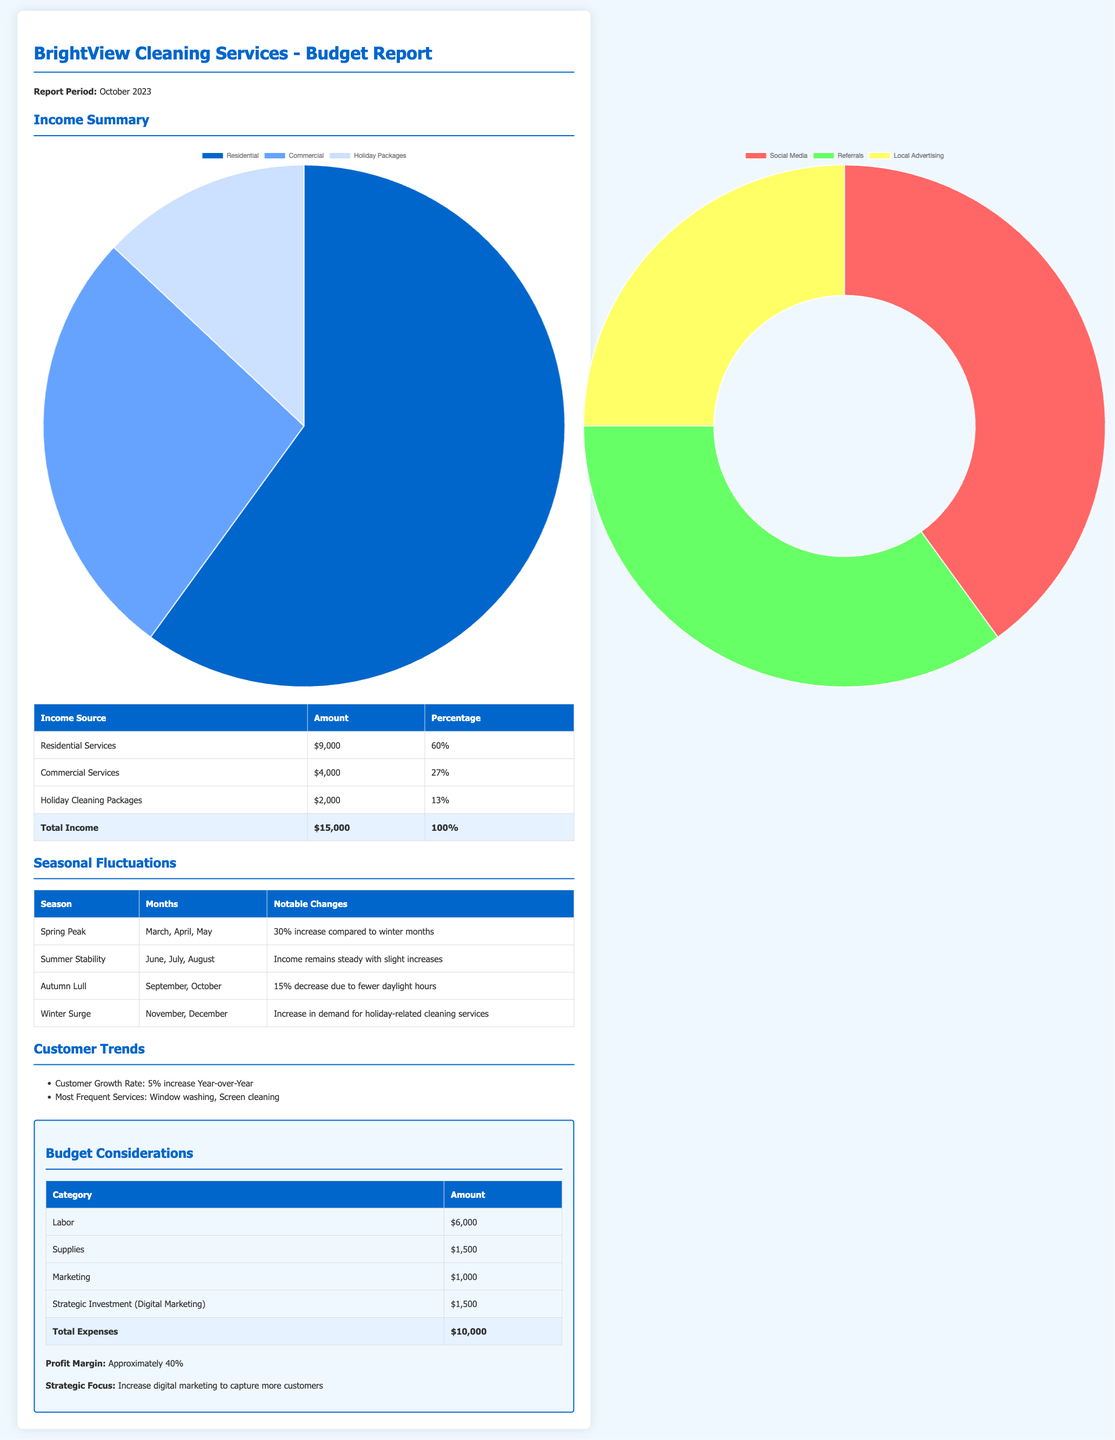What is the total income for October 2023? The total income is the sum of all the income sources listed, which is $9,000 + $4,000 + $2,000 = $15,000.
Answer: $15,000 What percentage of total income comes from residential services? Residential services account for 60% of the total income as stated in the income summary.
Answer: 60% What notable change occurs during the Autumn season? The document states that during Autumn, there is a 15% decrease in income due to fewer daylight hours.
Answer: 15% decrease What was the customer growth rate this year? The document mentions that the customer growth rate is a 5% increase year-over-year.
Answer: 5% What is the amount allocated for labor in the budget? The amount allocated for labor in the budget section is $6,000.
Answer: $6,000 Which income source has the highest percentage? The highest percentage income source is residential services, which is 60%.
Answer: Residential Services What is the profit margin for BrightView Cleaning Services? The profit margin stated in the document is approximately 40%.
Answer: 40% What strategic focus is suggested in the report? The strategic focus suggested is to increase digital marketing to capture more customers.
Answer: Increase digital marketing 